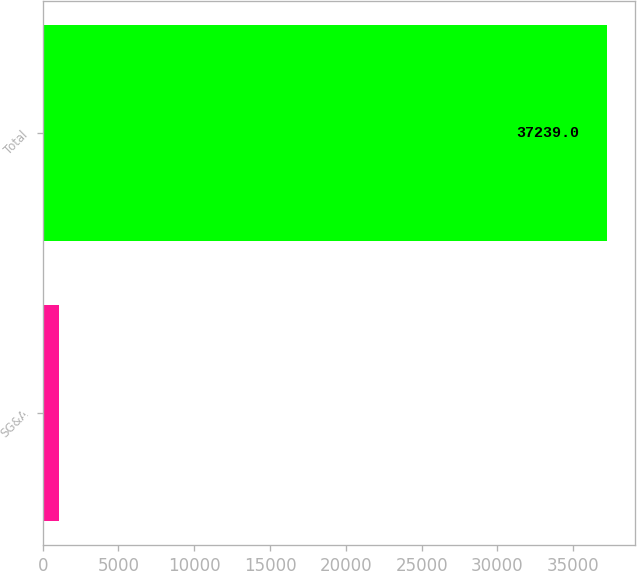Convert chart. <chart><loc_0><loc_0><loc_500><loc_500><bar_chart><fcel>SG&A<fcel>Total<nl><fcel>1050<fcel>37239<nl></chart> 